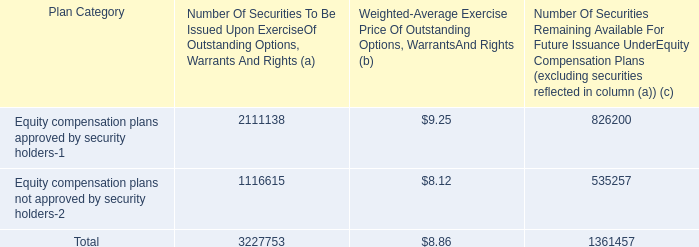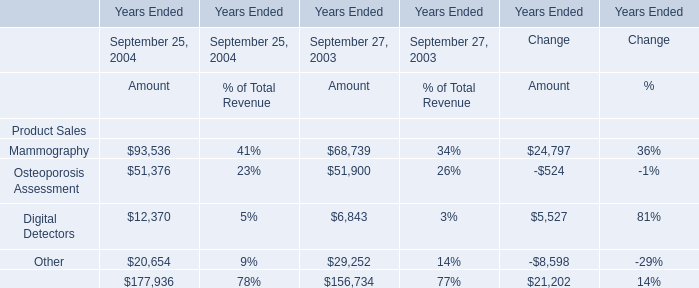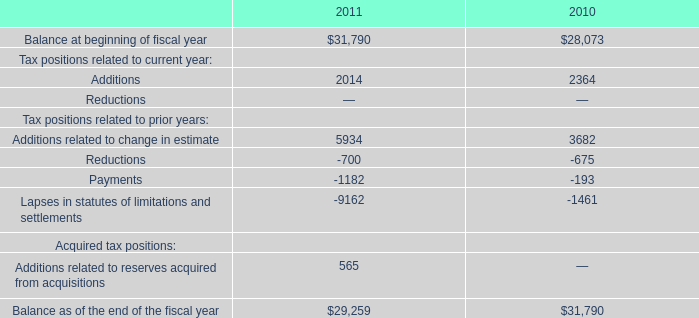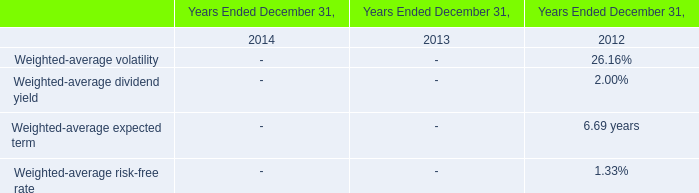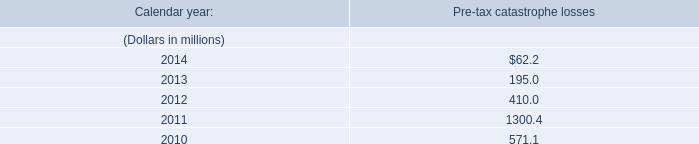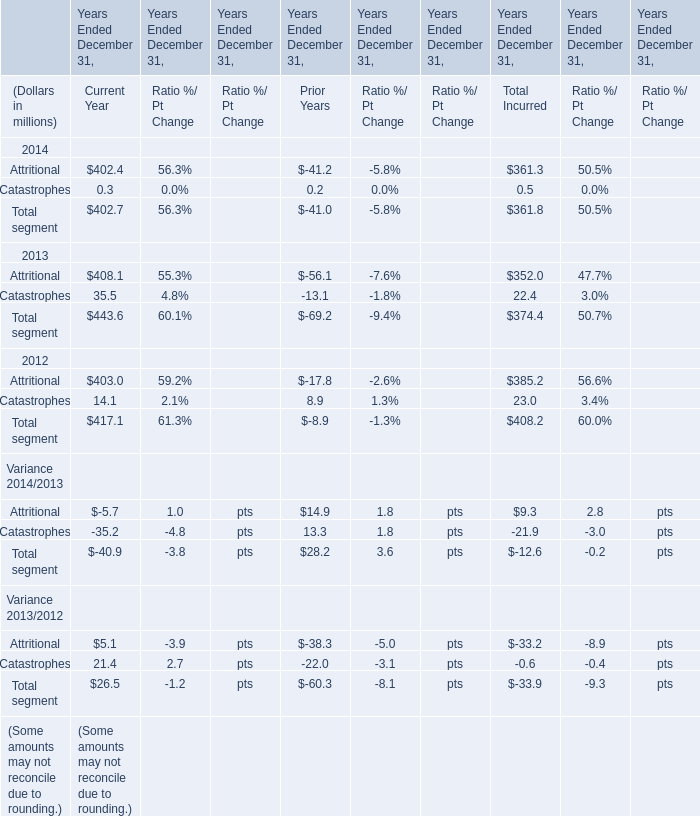What's the average of Other of Years Ended September 27, 2003 Amount, and Balance at beginning of fiscal year of 2010 ? 
Computations: ((29252.0 + 28073.0) / 2)
Answer: 28662.5. 